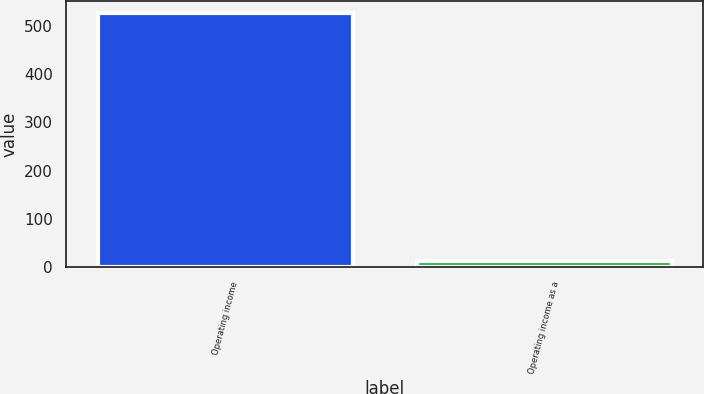<chart> <loc_0><loc_0><loc_500><loc_500><bar_chart><fcel>Operating income<fcel>Operating income as a<nl><fcel>525.6<fcel>11.5<nl></chart> 